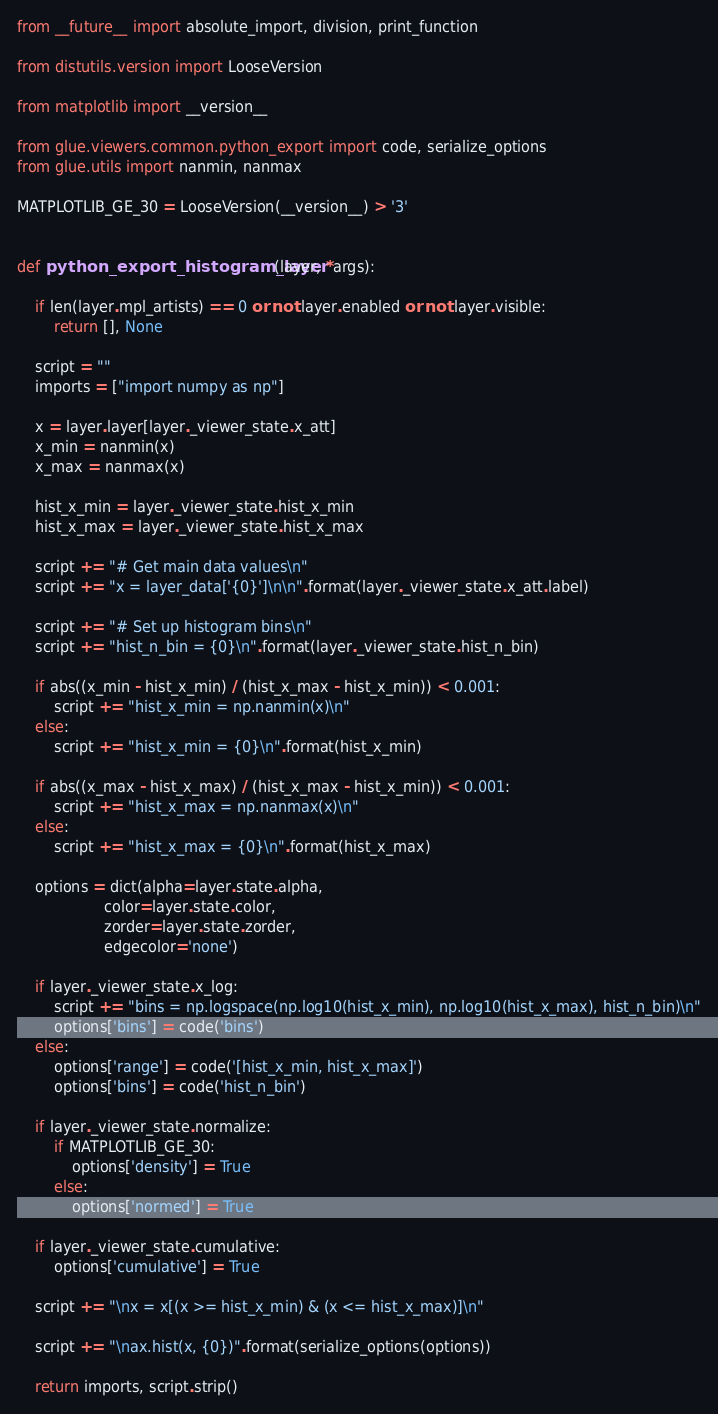Convert code to text. <code><loc_0><loc_0><loc_500><loc_500><_Python_>from __future__ import absolute_import, division, print_function

from distutils.version import LooseVersion

from matplotlib import __version__

from glue.viewers.common.python_export import code, serialize_options
from glue.utils import nanmin, nanmax

MATPLOTLIB_GE_30 = LooseVersion(__version__) > '3'


def python_export_histogram_layer(layer, *args):

    if len(layer.mpl_artists) == 0 or not layer.enabled or not layer.visible:
        return [], None

    script = ""
    imports = ["import numpy as np"]

    x = layer.layer[layer._viewer_state.x_att]
    x_min = nanmin(x)
    x_max = nanmax(x)

    hist_x_min = layer._viewer_state.hist_x_min
    hist_x_max = layer._viewer_state.hist_x_max

    script += "# Get main data values\n"
    script += "x = layer_data['{0}']\n\n".format(layer._viewer_state.x_att.label)

    script += "# Set up histogram bins\n"
    script += "hist_n_bin = {0}\n".format(layer._viewer_state.hist_n_bin)

    if abs((x_min - hist_x_min) / (hist_x_max - hist_x_min)) < 0.001:
        script += "hist_x_min = np.nanmin(x)\n"
    else:
        script += "hist_x_min = {0}\n".format(hist_x_min)

    if abs((x_max - hist_x_max) / (hist_x_max - hist_x_min)) < 0.001:
        script += "hist_x_max = np.nanmax(x)\n"
    else:
        script += "hist_x_max = {0}\n".format(hist_x_max)

    options = dict(alpha=layer.state.alpha,
                   color=layer.state.color,
                   zorder=layer.state.zorder,
                   edgecolor='none')

    if layer._viewer_state.x_log:
        script += "bins = np.logspace(np.log10(hist_x_min), np.log10(hist_x_max), hist_n_bin)\n"
        options['bins'] = code('bins')
    else:
        options['range'] = code('[hist_x_min, hist_x_max]')
        options['bins'] = code('hist_n_bin')

    if layer._viewer_state.normalize:
        if MATPLOTLIB_GE_30:
            options['density'] = True
        else:
            options['normed'] = True

    if layer._viewer_state.cumulative:
        options['cumulative'] = True

    script += "\nx = x[(x >= hist_x_min) & (x <= hist_x_max)]\n"

    script += "\nax.hist(x, {0})".format(serialize_options(options))

    return imports, script.strip()
</code> 